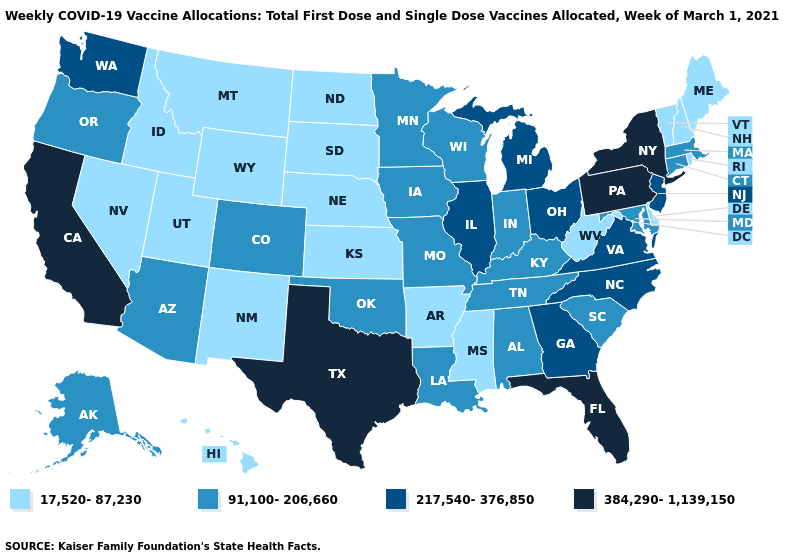Is the legend a continuous bar?
Keep it brief. No. What is the value of Oklahoma?
Be succinct. 91,100-206,660. Does Georgia have a higher value than California?
Be succinct. No. Name the states that have a value in the range 384,290-1,139,150?
Give a very brief answer. California, Florida, New York, Pennsylvania, Texas. Name the states that have a value in the range 17,520-87,230?
Concise answer only. Arkansas, Delaware, Hawaii, Idaho, Kansas, Maine, Mississippi, Montana, Nebraska, Nevada, New Hampshire, New Mexico, North Dakota, Rhode Island, South Dakota, Utah, Vermont, West Virginia, Wyoming. Name the states that have a value in the range 91,100-206,660?
Quick response, please. Alabama, Alaska, Arizona, Colorado, Connecticut, Indiana, Iowa, Kentucky, Louisiana, Maryland, Massachusetts, Minnesota, Missouri, Oklahoma, Oregon, South Carolina, Tennessee, Wisconsin. Among the states that border Maryland , does Pennsylvania have the highest value?
Give a very brief answer. Yes. Among the states that border Kentucky , which have the lowest value?
Concise answer only. West Virginia. Among the states that border Iowa , which have the highest value?
Write a very short answer. Illinois. Name the states that have a value in the range 91,100-206,660?
Keep it brief. Alabama, Alaska, Arizona, Colorado, Connecticut, Indiana, Iowa, Kentucky, Louisiana, Maryland, Massachusetts, Minnesota, Missouri, Oklahoma, Oregon, South Carolina, Tennessee, Wisconsin. Does Connecticut have a lower value than Georgia?
Be succinct. Yes. Name the states that have a value in the range 217,540-376,850?
Short answer required. Georgia, Illinois, Michigan, New Jersey, North Carolina, Ohio, Virginia, Washington. Which states hav the highest value in the MidWest?
Answer briefly. Illinois, Michigan, Ohio. What is the value of Kansas?
Keep it brief. 17,520-87,230. 